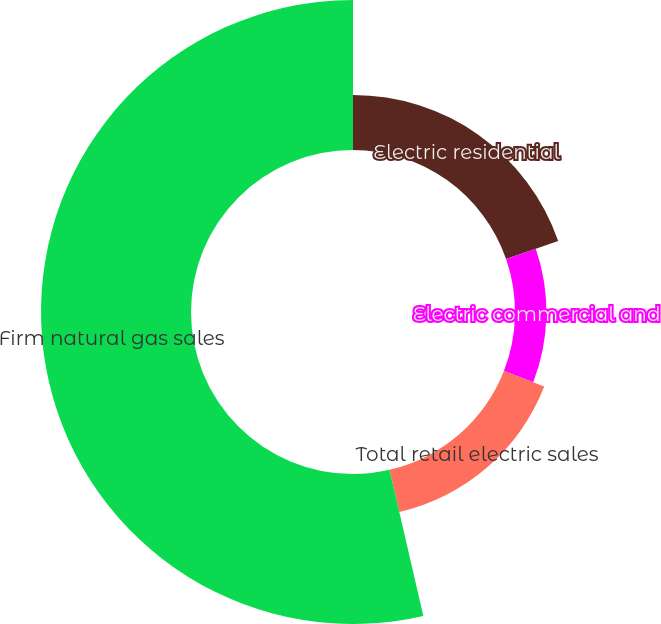Convert chart to OTSL. <chart><loc_0><loc_0><loc_500><loc_500><pie_chart><fcel>Electric residential<fcel>Electric commercial and<fcel>Total retail electric sales<fcel>Firm natural gas sales<nl><fcel>19.7%<fcel>11.22%<fcel>15.46%<fcel>53.62%<nl></chart> 